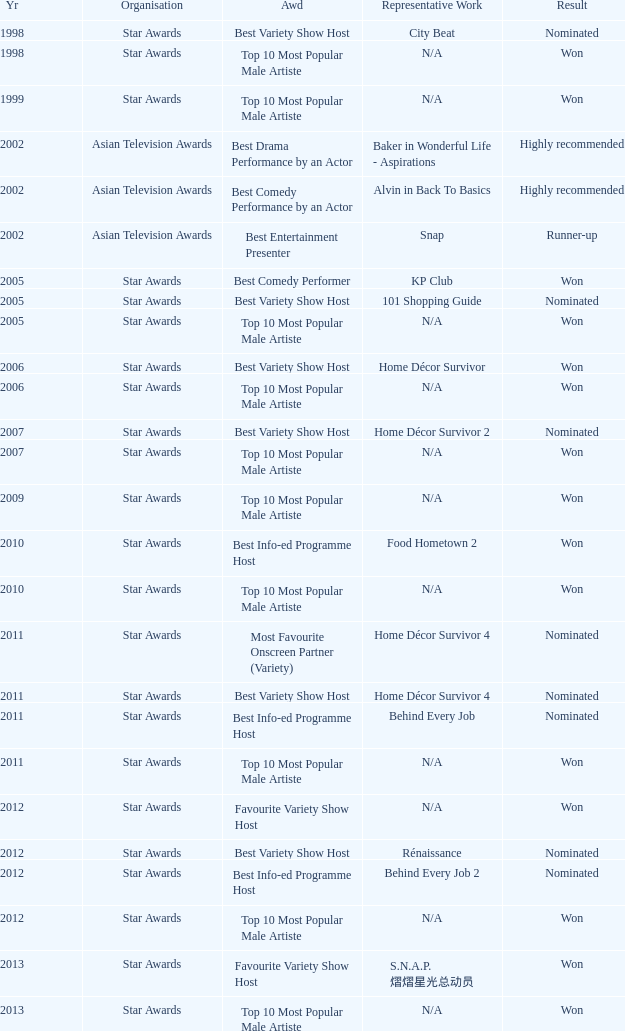What is the name of the award in a year more than 2005, and the Result of nominated? Best Variety Show Host, Most Favourite Onscreen Partner (Variety), Best Variety Show Host, Best Info-ed Programme Host, Best Variety Show Host, Best Info-ed Programme Host, Best Info-Ed Programme Host, Best Variety Show Host. 